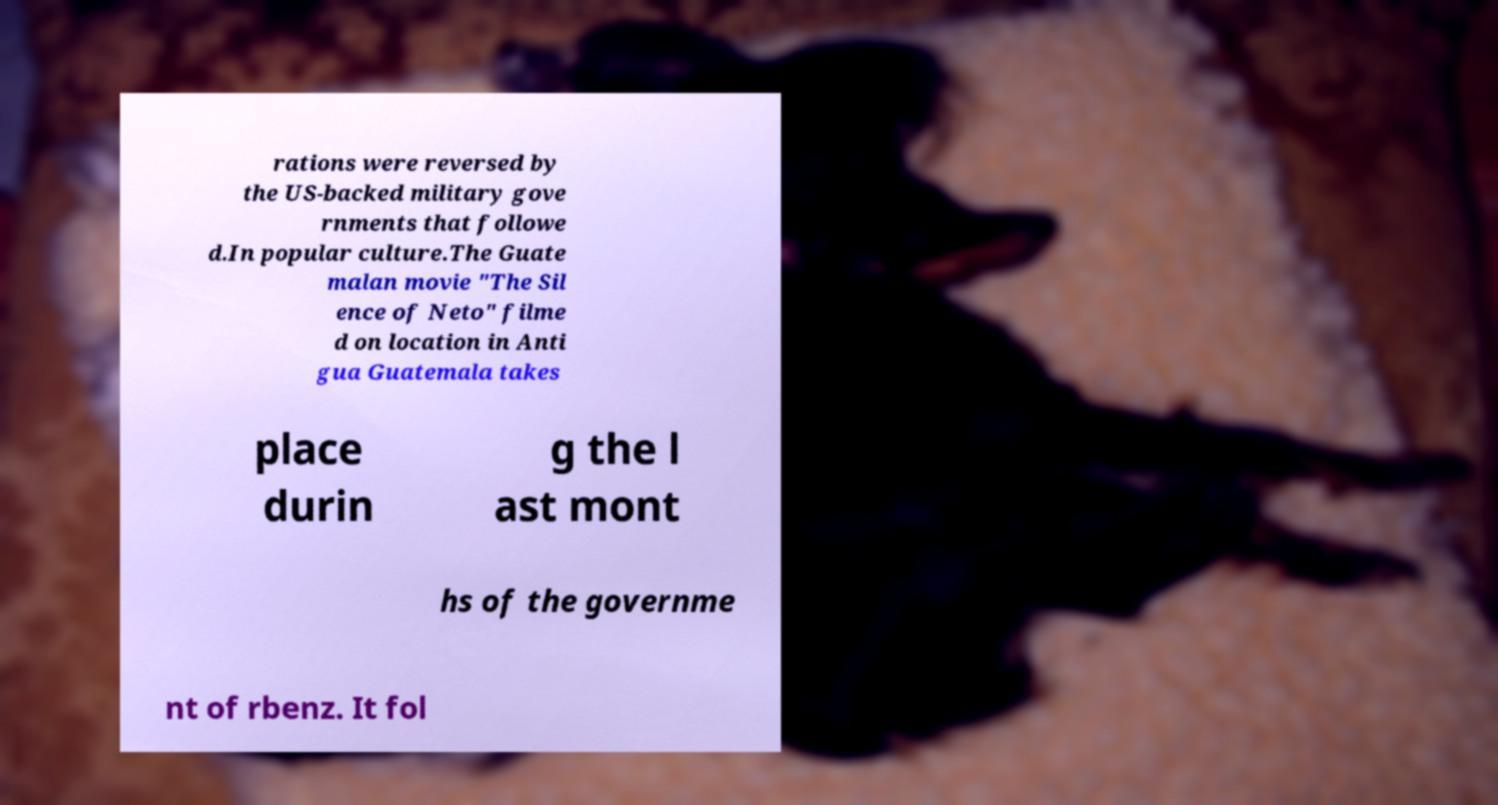Please identify and transcribe the text found in this image. rations were reversed by the US-backed military gove rnments that followe d.In popular culture.The Guate malan movie "The Sil ence of Neto" filme d on location in Anti gua Guatemala takes place durin g the l ast mont hs of the governme nt of rbenz. It fol 